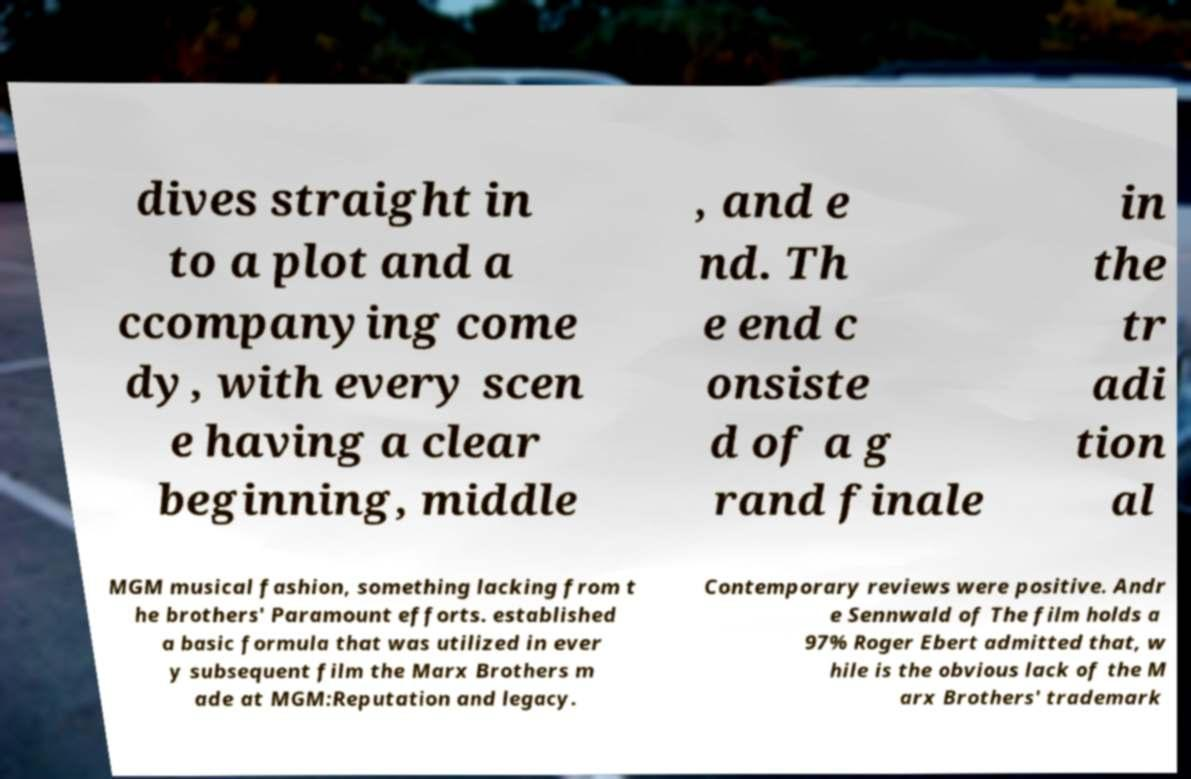I need the written content from this picture converted into text. Can you do that? dives straight in to a plot and a ccompanying come dy, with every scen e having a clear beginning, middle , and e nd. Th e end c onsiste d of a g rand finale in the tr adi tion al MGM musical fashion, something lacking from t he brothers' Paramount efforts. established a basic formula that was utilized in ever y subsequent film the Marx Brothers m ade at MGM:Reputation and legacy. Contemporary reviews were positive. Andr e Sennwald of The film holds a 97% Roger Ebert admitted that, w hile is the obvious lack of the M arx Brothers' trademark 